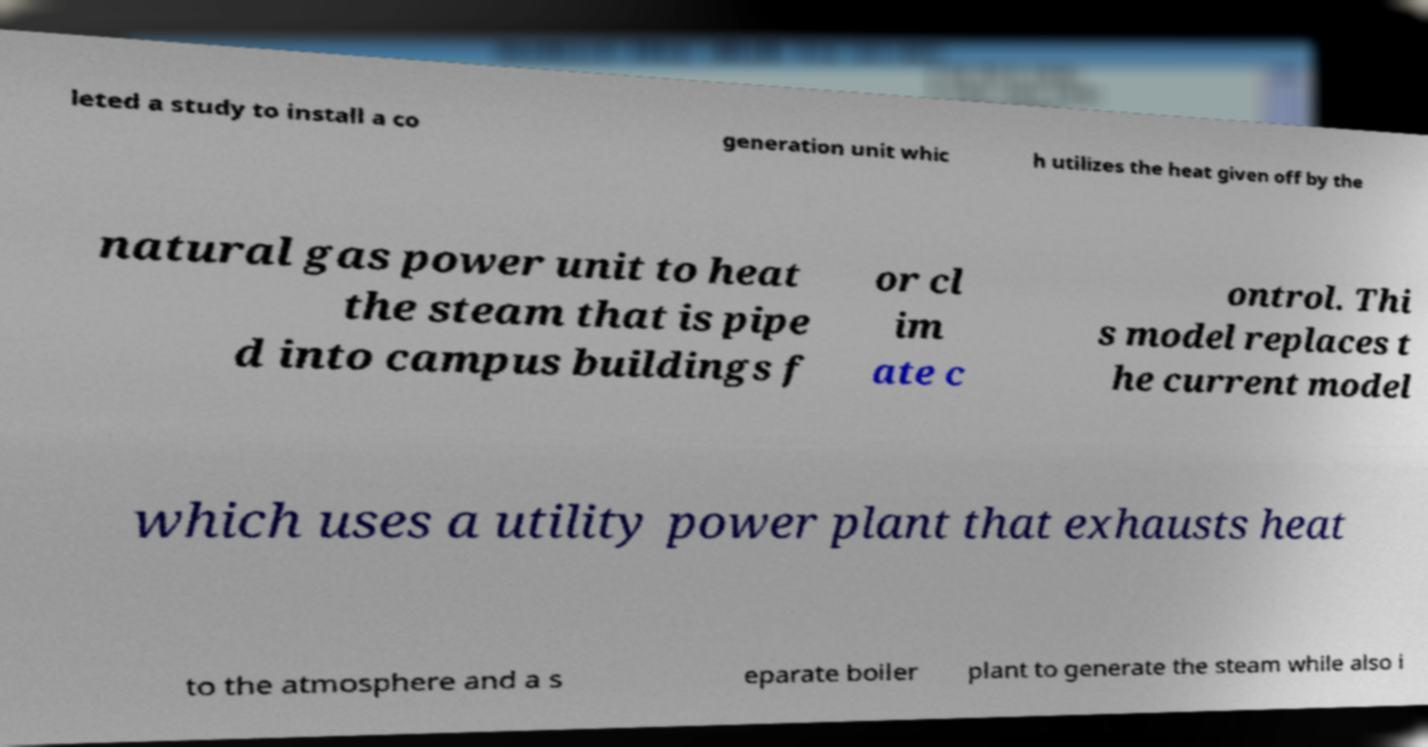Could you extract and type out the text from this image? leted a study to install a co generation unit whic h utilizes the heat given off by the natural gas power unit to heat the steam that is pipe d into campus buildings f or cl im ate c ontrol. Thi s model replaces t he current model which uses a utility power plant that exhausts heat to the atmosphere and a s eparate boiler plant to generate the steam while also i 